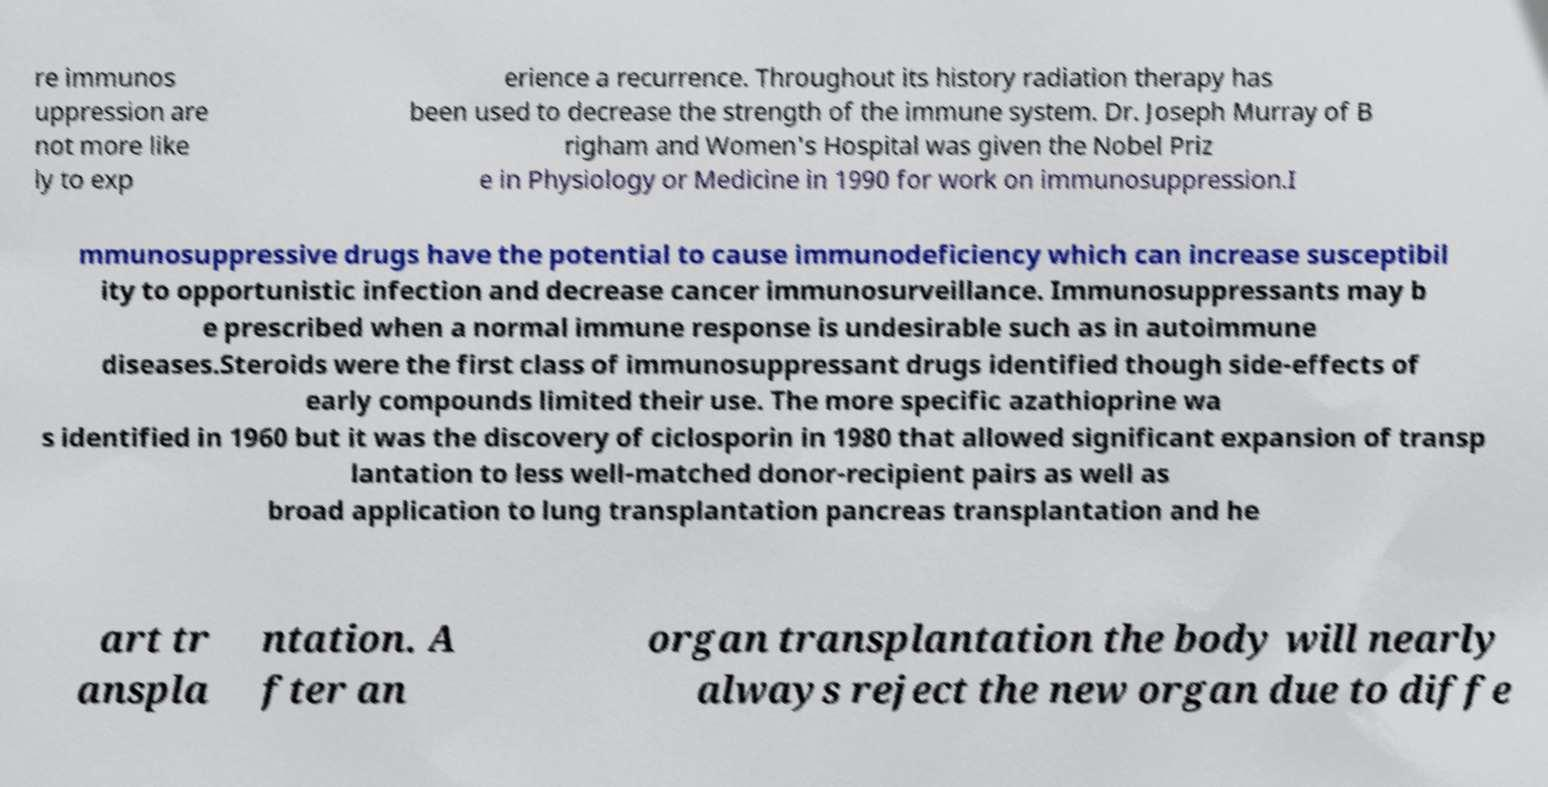For documentation purposes, I need the text within this image transcribed. Could you provide that? re immunos uppression are not more like ly to exp erience a recurrence. Throughout its history radiation therapy has been used to decrease the strength of the immune system. Dr. Joseph Murray of B righam and Women's Hospital was given the Nobel Priz e in Physiology or Medicine in 1990 for work on immunosuppression.I mmunosuppressive drugs have the potential to cause immunodeficiency which can increase susceptibil ity to opportunistic infection and decrease cancer immunosurveillance. Immunosuppressants may b e prescribed when a normal immune response is undesirable such as in autoimmune diseases.Steroids were the first class of immunosuppressant drugs identified though side-effects of early compounds limited their use. The more specific azathioprine wa s identified in 1960 but it was the discovery of ciclosporin in 1980 that allowed significant expansion of transp lantation to less well-matched donor-recipient pairs as well as broad application to lung transplantation pancreas transplantation and he art tr anspla ntation. A fter an organ transplantation the body will nearly always reject the new organ due to diffe 